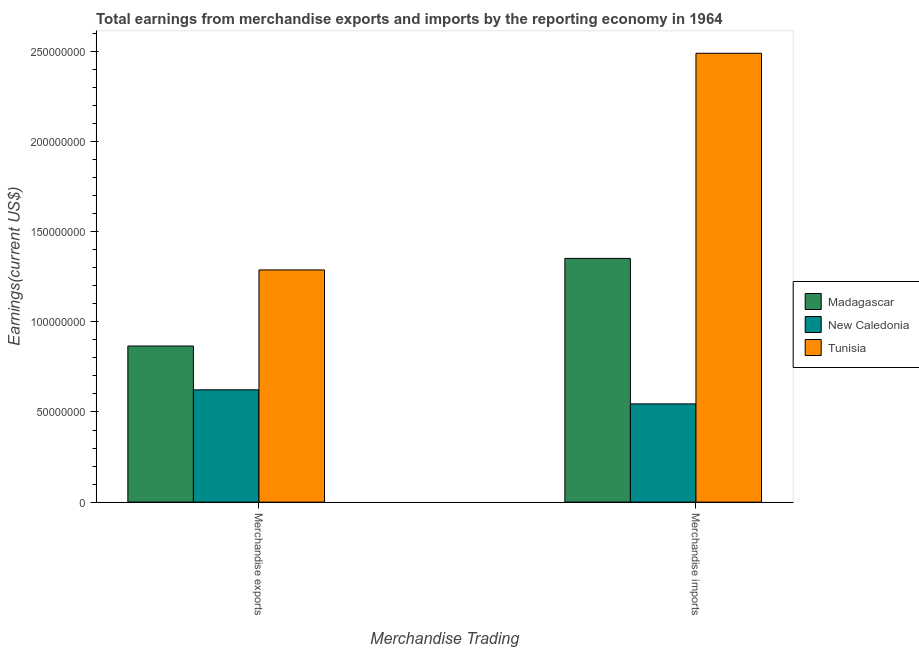How many groups of bars are there?
Your answer should be compact. 2. How many bars are there on the 1st tick from the left?
Ensure brevity in your answer.  3. How many bars are there on the 1st tick from the right?
Ensure brevity in your answer.  3. What is the earnings from merchandise imports in New Caledonia?
Make the answer very short. 5.45e+07. Across all countries, what is the maximum earnings from merchandise exports?
Make the answer very short. 1.29e+08. Across all countries, what is the minimum earnings from merchandise imports?
Give a very brief answer. 5.45e+07. In which country was the earnings from merchandise imports maximum?
Make the answer very short. Tunisia. In which country was the earnings from merchandise imports minimum?
Your response must be concise. New Caledonia. What is the total earnings from merchandise exports in the graph?
Provide a succinct answer. 2.78e+08. What is the difference between the earnings from merchandise exports in New Caledonia and that in Tunisia?
Your response must be concise. -6.65e+07. What is the difference between the earnings from merchandise exports in Madagascar and the earnings from merchandise imports in Tunisia?
Give a very brief answer. -1.62e+08. What is the average earnings from merchandise imports per country?
Offer a very short reply. 1.46e+08. What is the difference between the earnings from merchandise exports and earnings from merchandise imports in Madagascar?
Your answer should be compact. -4.86e+07. In how many countries, is the earnings from merchandise exports greater than 250000000 US$?
Offer a very short reply. 0. What is the ratio of the earnings from merchandise exports in New Caledonia to that in Madagascar?
Ensure brevity in your answer.  0.72. Is the earnings from merchandise imports in Madagascar less than that in New Caledonia?
Your answer should be very brief. No. In how many countries, is the earnings from merchandise exports greater than the average earnings from merchandise exports taken over all countries?
Your answer should be compact. 1. What does the 1st bar from the left in Merchandise exports represents?
Offer a very short reply. Madagascar. What does the 3rd bar from the right in Merchandise imports represents?
Offer a very short reply. Madagascar. How many countries are there in the graph?
Provide a short and direct response. 3. What is the difference between two consecutive major ticks on the Y-axis?
Provide a succinct answer. 5.00e+07. Does the graph contain grids?
Provide a short and direct response. No. Where does the legend appear in the graph?
Give a very brief answer. Center right. How are the legend labels stacked?
Make the answer very short. Vertical. What is the title of the graph?
Ensure brevity in your answer.  Total earnings from merchandise exports and imports by the reporting economy in 1964. What is the label or title of the X-axis?
Keep it short and to the point. Merchandise Trading. What is the label or title of the Y-axis?
Ensure brevity in your answer.  Earnings(current US$). What is the Earnings(current US$) of Madagascar in Merchandise exports?
Offer a terse response. 8.66e+07. What is the Earnings(current US$) of New Caledonia in Merchandise exports?
Ensure brevity in your answer.  6.23e+07. What is the Earnings(current US$) of Tunisia in Merchandise exports?
Your answer should be very brief. 1.29e+08. What is the Earnings(current US$) of Madagascar in Merchandise imports?
Ensure brevity in your answer.  1.35e+08. What is the Earnings(current US$) in New Caledonia in Merchandise imports?
Your answer should be compact. 5.45e+07. What is the Earnings(current US$) in Tunisia in Merchandise imports?
Make the answer very short. 2.49e+08. Across all Merchandise Trading, what is the maximum Earnings(current US$) in Madagascar?
Your answer should be compact. 1.35e+08. Across all Merchandise Trading, what is the maximum Earnings(current US$) in New Caledonia?
Give a very brief answer. 6.23e+07. Across all Merchandise Trading, what is the maximum Earnings(current US$) in Tunisia?
Your answer should be very brief. 2.49e+08. Across all Merchandise Trading, what is the minimum Earnings(current US$) of Madagascar?
Keep it short and to the point. 8.66e+07. Across all Merchandise Trading, what is the minimum Earnings(current US$) in New Caledonia?
Provide a succinct answer. 5.45e+07. Across all Merchandise Trading, what is the minimum Earnings(current US$) of Tunisia?
Your response must be concise. 1.29e+08. What is the total Earnings(current US$) of Madagascar in the graph?
Provide a succinct answer. 2.22e+08. What is the total Earnings(current US$) in New Caledonia in the graph?
Provide a succinct answer. 1.17e+08. What is the total Earnings(current US$) of Tunisia in the graph?
Provide a succinct answer. 3.78e+08. What is the difference between the Earnings(current US$) of Madagascar in Merchandise exports and that in Merchandise imports?
Your answer should be very brief. -4.86e+07. What is the difference between the Earnings(current US$) in New Caledonia in Merchandise exports and that in Merchandise imports?
Give a very brief answer. 7.80e+06. What is the difference between the Earnings(current US$) in Tunisia in Merchandise exports and that in Merchandise imports?
Give a very brief answer. -1.20e+08. What is the difference between the Earnings(current US$) of Madagascar in Merchandise exports and the Earnings(current US$) of New Caledonia in Merchandise imports?
Provide a short and direct response. 3.21e+07. What is the difference between the Earnings(current US$) of Madagascar in Merchandise exports and the Earnings(current US$) of Tunisia in Merchandise imports?
Ensure brevity in your answer.  -1.62e+08. What is the difference between the Earnings(current US$) of New Caledonia in Merchandise exports and the Earnings(current US$) of Tunisia in Merchandise imports?
Your answer should be compact. -1.87e+08. What is the average Earnings(current US$) in Madagascar per Merchandise Trading?
Keep it short and to the point. 1.11e+08. What is the average Earnings(current US$) in New Caledonia per Merchandise Trading?
Your answer should be compact. 5.84e+07. What is the average Earnings(current US$) in Tunisia per Merchandise Trading?
Give a very brief answer. 1.89e+08. What is the difference between the Earnings(current US$) in Madagascar and Earnings(current US$) in New Caledonia in Merchandise exports?
Give a very brief answer. 2.43e+07. What is the difference between the Earnings(current US$) in Madagascar and Earnings(current US$) in Tunisia in Merchandise exports?
Offer a very short reply. -4.22e+07. What is the difference between the Earnings(current US$) of New Caledonia and Earnings(current US$) of Tunisia in Merchandise exports?
Make the answer very short. -6.65e+07. What is the difference between the Earnings(current US$) of Madagascar and Earnings(current US$) of New Caledonia in Merchandise imports?
Your answer should be compact. 8.07e+07. What is the difference between the Earnings(current US$) in Madagascar and Earnings(current US$) in Tunisia in Merchandise imports?
Give a very brief answer. -1.14e+08. What is the difference between the Earnings(current US$) of New Caledonia and Earnings(current US$) of Tunisia in Merchandise imports?
Your answer should be compact. -1.94e+08. What is the ratio of the Earnings(current US$) of Madagascar in Merchandise exports to that in Merchandise imports?
Provide a short and direct response. 0.64. What is the ratio of the Earnings(current US$) in New Caledonia in Merchandise exports to that in Merchandise imports?
Your answer should be very brief. 1.14. What is the ratio of the Earnings(current US$) in Tunisia in Merchandise exports to that in Merchandise imports?
Offer a terse response. 0.52. What is the difference between the highest and the second highest Earnings(current US$) of Madagascar?
Provide a short and direct response. 4.86e+07. What is the difference between the highest and the second highest Earnings(current US$) of New Caledonia?
Give a very brief answer. 7.80e+06. What is the difference between the highest and the second highest Earnings(current US$) in Tunisia?
Make the answer very short. 1.20e+08. What is the difference between the highest and the lowest Earnings(current US$) in Madagascar?
Offer a terse response. 4.86e+07. What is the difference between the highest and the lowest Earnings(current US$) of New Caledonia?
Provide a short and direct response. 7.80e+06. What is the difference between the highest and the lowest Earnings(current US$) of Tunisia?
Your response must be concise. 1.20e+08. 